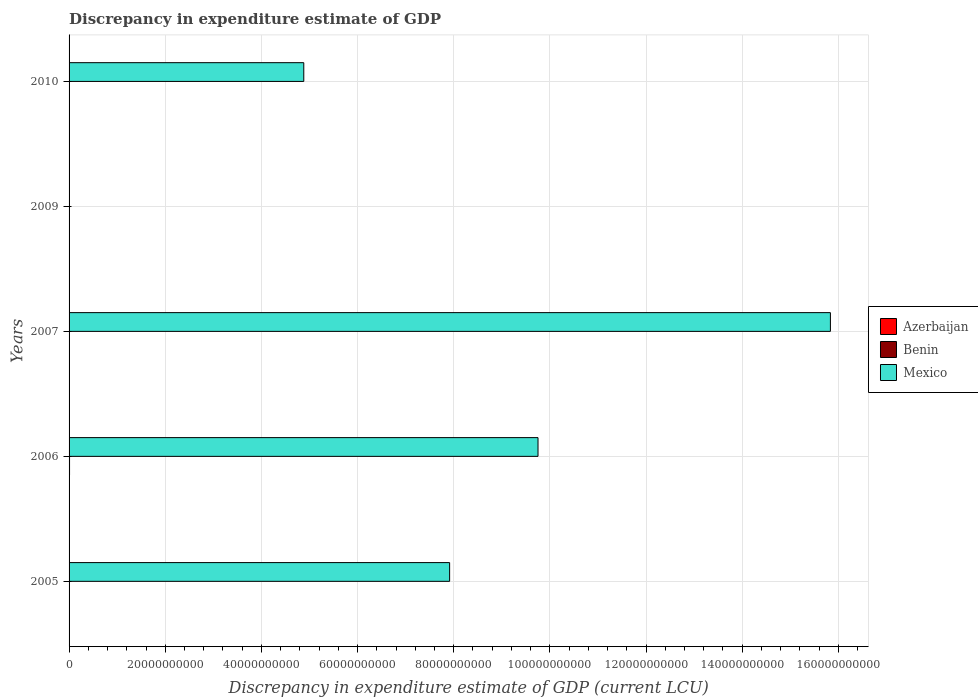How many different coloured bars are there?
Your answer should be very brief. 2. Are the number of bars per tick equal to the number of legend labels?
Your answer should be compact. No. Are the number of bars on each tick of the Y-axis equal?
Your answer should be very brief. No. How many bars are there on the 2nd tick from the bottom?
Give a very brief answer. 2. What is the label of the 4th group of bars from the top?
Keep it short and to the point. 2006. What is the discrepancy in expenditure estimate of GDP in Mexico in 2009?
Offer a terse response. 0. Across all years, what is the maximum discrepancy in expenditure estimate of GDP in Mexico?
Ensure brevity in your answer.  1.58e+11. In which year was the discrepancy in expenditure estimate of GDP in Mexico maximum?
Offer a terse response. 2007. What is the total discrepancy in expenditure estimate of GDP in Benin in the graph?
Offer a terse response. 1.00e+08. What is the difference between the discrepancy in expenditure estimate of GDP in Mexico in 2006 and that in 2010?
Provide a succinct answer. 4.87e+1. What is the difference between the discrepancy in expenditure estimate of GDP in Mexico in 2010 and the discrepancy in expenditure estimate of GDP in Benin in 2009?
Your answer should be very brief. 4.88e+1. In how many years, is the discrepancy in expenditure estimate of GDP in Benin greater than 116000000000 LCU?
Keep it short and to the point. 0. Is the discrepancy in expenditure estimate of GDP in Mexico in 2005 less than that in 2007?
Make the answer very short. Yes. What is the difference between the highest and the second highest discrepancy in expenditure estimate of GDP in Mexico?
Provide a succinct answer. 6.08e+1. What is the difference between the highest and the lowest discrepancy in expenditure estimate of GDP in Mexico?
Offer a terse response. 1.58e+11. Is it the case that in every year, the sum of the discrepancy in expenditure estimate of GDP in Benin and discrepancy in expenditure estimate of GDP in Mexico is greater than the discrepancy in expenditure estimate of GDP in Azerbaijan?
Offer a terse response. No. How many years are there in the graph?
Offer a terse response. 5. What is the difference between two consecutive major ticks on the X-axis?
Provide a succinct answer. 2.00e+1. Are the values on the major ticks of X-axis written in scientific E-notation?
Ensure brevity in your answer.  No. Does the graph contain any zero values?
Make the answer very short. Yes. Where does the legend appear in the graph?
Your answer should be very brief. Center right. How are the legend labels stacked?
Your response must be concise. Vertical. What is the title of the graph?
Keep it short and to the point. Discrepancy in expenditure estimate of GDP. Does "Dominican Republic" appear as one of the legend labels in the graph?
Your response must be concise. No. What is the label or title of the X-axis?
Provide a short and direct response. Discrepancy in expenditure estimate of GDP (current LCU). What is the label or title of the Y-axis?
Give a very brief answer. Years. What is the Discrepancy in expenditure estimate of GDP (current LCU) in Azerbaijan in 2005?
Keep it short and to the point. 0. What is the Discrepancy in expenditure estimate of GDP (current LCU) in Mexico in 2005?
Keep it short and to the point. 7.92e+1. What is the Discrepancy in expenditure estimate of GDP (current LCU) in Benin in 2006?
Offer a very short reply. 1.00e+08. What is the Discrepancy in expenditure estimate of GDP (current LCU) in Mexico in 2006?
Ensure brevity in your answer.  9.75e+1. What is the Discrepancy in expenditure estimate of GDP (current LCU) in Azerbaijan in 2007?
Provide a succinct answer. 0. What is the Discrepancy in expenditure estimate of GDP (current LCU) in Benin in 2007?
Keep it short and to the point. 0. What is the Discrepancy in expenditure estimate of GDP (current LCU) of Mexico in 2007?
Offer a terse response. 1.58e+11. What is the Discrepancy in expenditure estimate of GDP (current LCU) in Azerbaijan in 2009?
Your response must be concise. 0. What is the Discrepancy in expenditure estimate of GDP (current LCU) of Benin in 2009?
Your answer should be compact. 0. What is the Discrepancy in expenditure estimate of GDP (current LCU) in Azerbaijan in 2010?
Provide a succinct answer. 0. What is the Discrepancy in expenditure estimate of GDP (current LCU) of Mexico in 2010?
Provide a succinct answer. 4.88e+1. Across all years, what is the maximum Discrepancy in expenditure estimate of GDP (current LCU) in Benin?
Your response must be concise. 1.00e+08. Across all years, what is the maximum Discrepancy in expenditure estimate of GDP (current LCU) in Mexico?
Provide a short and direct response. 1.58e+11. Across all years, what is the minimum Discrepancy in expenditure estimate of GDP (current LCU) of Mexico?
Provide a succinct answer. 0. What is the total Discrepancy in expenditure estimate of GDP (current LCU) in Benin in the graph?
Your response must be concise. 1.00e+08. What is the total Discrepancy in expenditure estimate of GDP (current LCU) of Mexico in the graph?
Your answer should be compact. 3.84e+11. What is the difference between the Discrepancy in expenditure estimate of GDP (current LCU) of Mexico in 2005 and that in 2006?
Your answer should be very brief. -1.84e+1. What is the difference between the Discrepancy in expenditure estimate of GDP (current LCU) in Mexico in 2005 and that in 2007?
Make the answer very short. -7.92e+1. What is the difference between the Discrepancy in expenditure estimate of GDP (current LCU) in Mexico in 2005 and that in 2010?
Your answer should be compact. 3.03e+1. What is the difference between the Discrepancy in expenditure estimate of GDP (current LCU) of Mexico in 2006 and that in 2007?
Provide a succinct answer. -6.08e+1. What is the difference between the Discrepancy in expenditure estimate of GDP (current LCU) of Mexico in 2006 and that in 2010?
Provide a succinct answer. 4.87e+1. What is the difference between the Discrepancy in expenditure estimate of GDP (current LCU) in Mexico in 2007 and that in 2010?
Give a very brief answer. 1.10e+11. What is the difference between the Discrepancy in expenditure estimate of GDP (current LCU) in Benin in 2006 and the Discrepancy in expenditure estimate of GDP (current LCU) in Mexico in 2007?
Offer a terse response. -1.58e+11. What is the difference between the Discrepancy in expenditure estimate of GDP (current LCU) of Benin in 2006 and the Discrepancy in expenditure estimate of GDP (current LCU) of Mexico in 2010?
Your response must be concise. -4.87e+1. What is the average Discrepancy in expenditure estimate of GDP (current LCU) of Azerbaijan per year?
Keep it short and to the point. 0. What is the average Discrepancy in expenditure estimate of GDP (current LCU) in Benin per year?
Ensure brevity in your answer.  2.00e+07. What is the average Discrepancy in expenditure estimate of GDP (current LCU) in Mexico per year?
Provide a succinct answer. 7.68e+1. In the year 2006, what is the difference between the Discrepancy in expenditure estimate of GDP (current LCU) in Benin and Discrepancy in expenditure estimate of GDP (current LCU) in Mexico?
Keep it short and to the point. -9.74e+1. What is the ratio of the Discrepancy in expenditure estimate of GDP (current LCU) in Mexico in 2005 to that in 2006?
Ensure brevity in your answer.  0.81. What is the ratio of the Discrepancy in expenditure estimate of GDP (current LCU) of Mexico in 2005 to that in 2007?
Provide a succinct answer. 0.5. What is the ratio of the Discrepancy in expenditure estimate of GDP (current LCU) of Mexico in 2005 to that in 2010?
Provide a short and direct response. 1.62. What is the ratio of the Discrepancy in expenditure estimate of GDP (current LCU) of Mexico in 2006 to that in 2007?
Offer a terse response. 0.62. What is the ratio of the Discrepancy in expenditure estimate of GDP (current LCU) in Mexico in 2006 to that in 2010?
Your answer should be very brief. 2. What is the ratio of the Discrepancy in expenditure estimate of GDP (current LCU) in Mexico in 2007 to that in 2010?
Offer a very short reply. 3.24. What is the difference between the highest and the second highest Discrepancy in expenditure estimate of GDP (current LCU) of Mexico?
Offer a terse response. 6.08e+1. What is the difference between the highest and the lowest Discrepancy in expenditure estimate of GDP (current LCU) of Benin?
Provide a short and direct response. 1.00e+08. What is the difference between the highest and the lowest Discrepancy in expenditure estimate of GDP (current LCU) of Mexico?
Provide a short and direct response. 1.58e+11. 